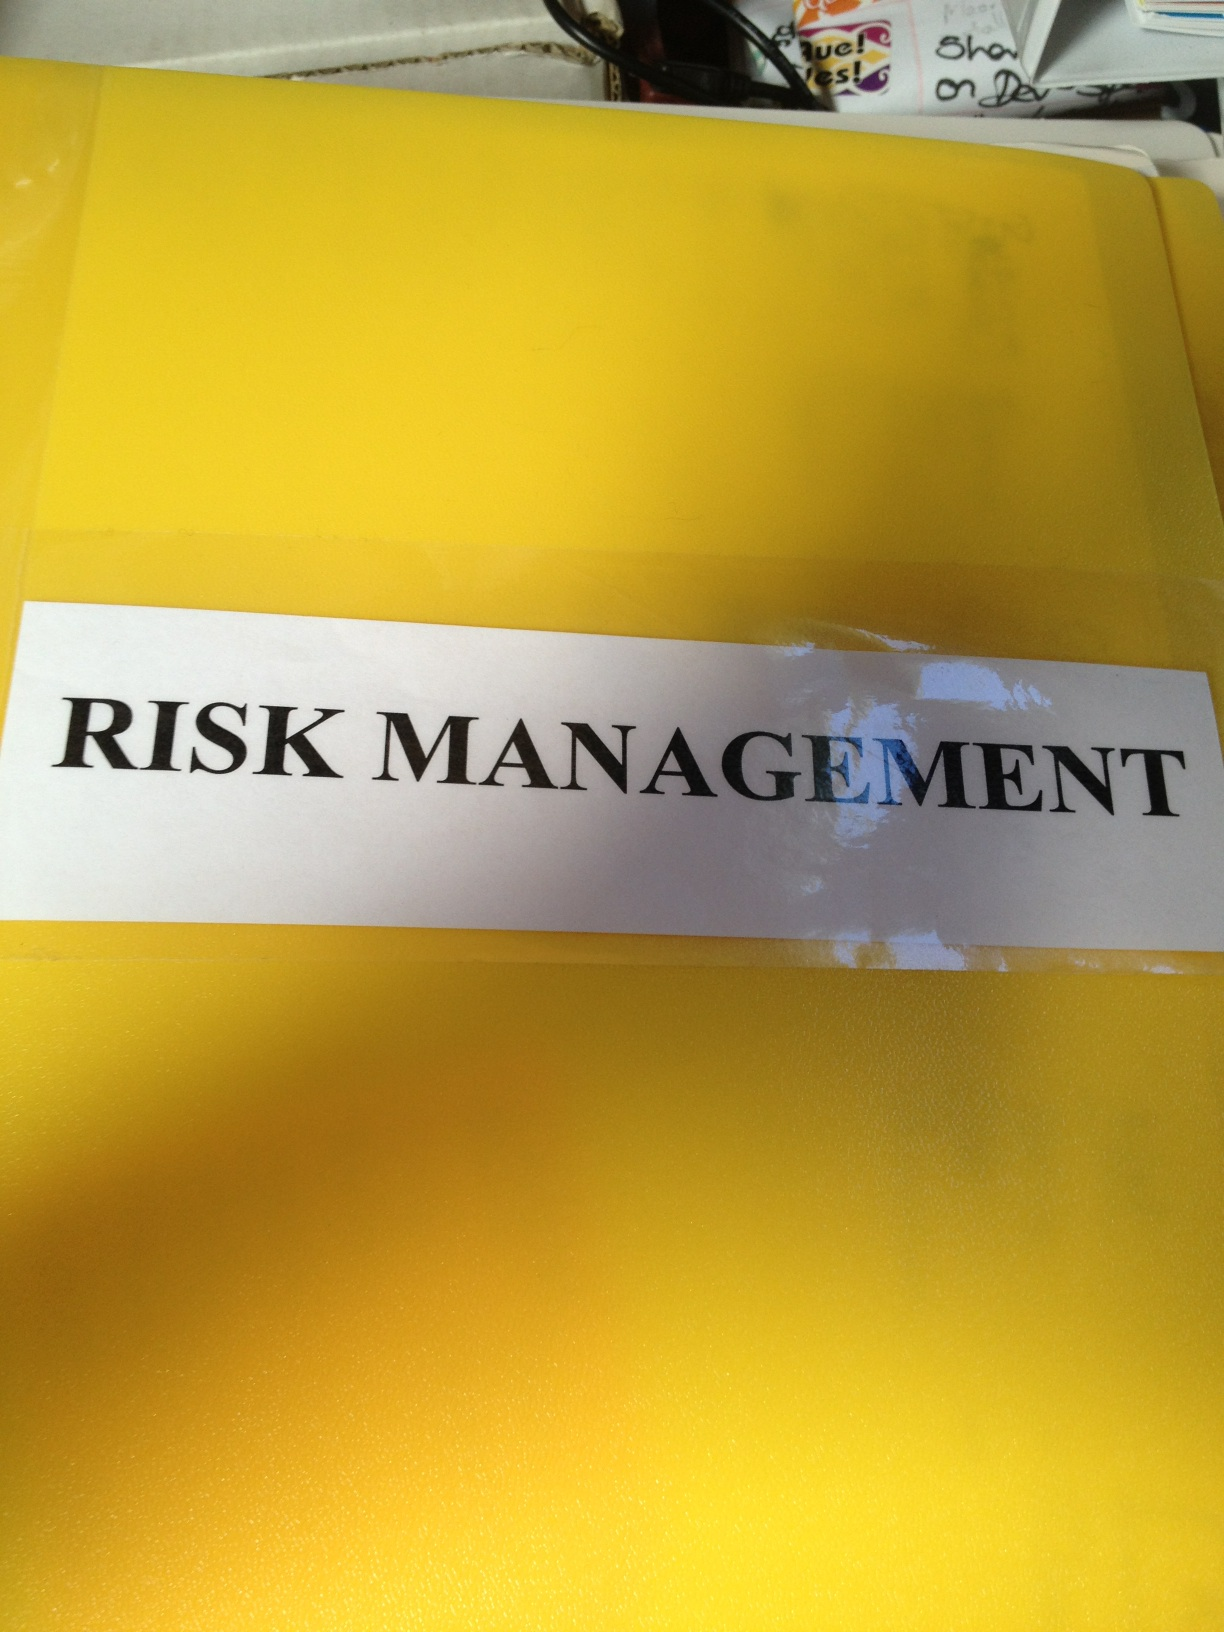What is the title on this photo? The title on the photo reads "RISK MANAGEMENT." 